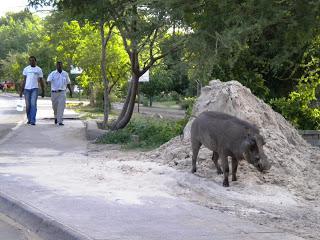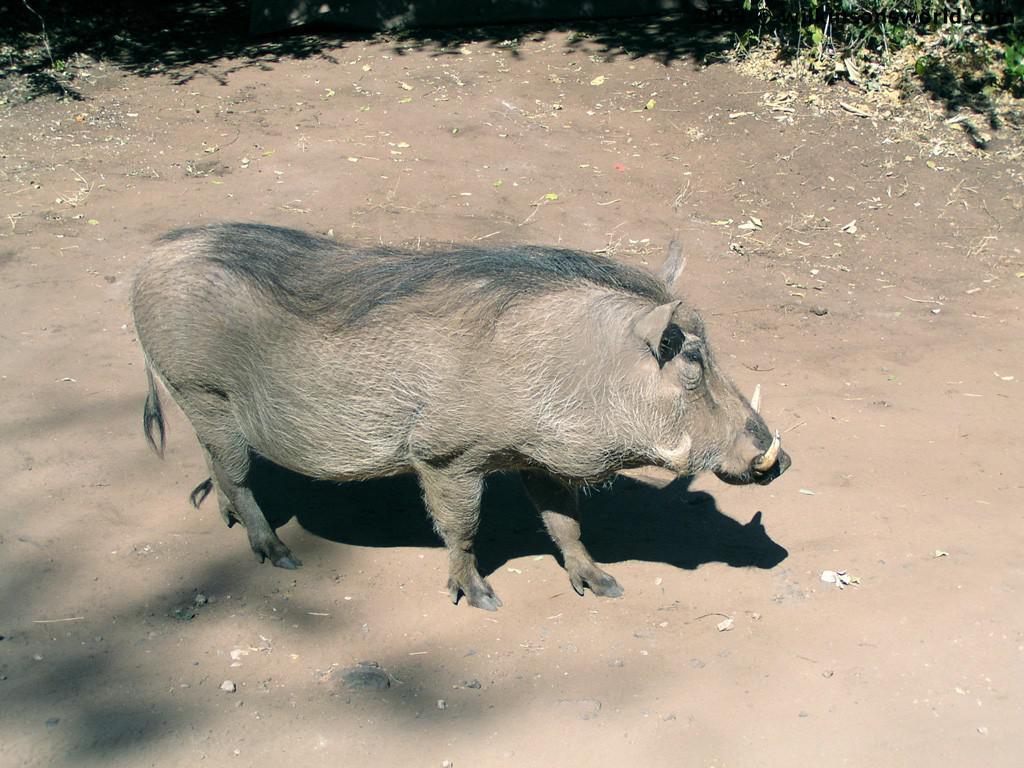The first image is the image on the left, the second image is the image on the right. Examine the images to the left and right. Is the description "There is at least one person in one of the pictures." accurate? Answer yes or no. Yes. The first image is the image on the left, the second image is the image on the right. For the images displayed, is the sentence "There is more than one kind of animal in the images." factually correct? Answer yes or no. No. 